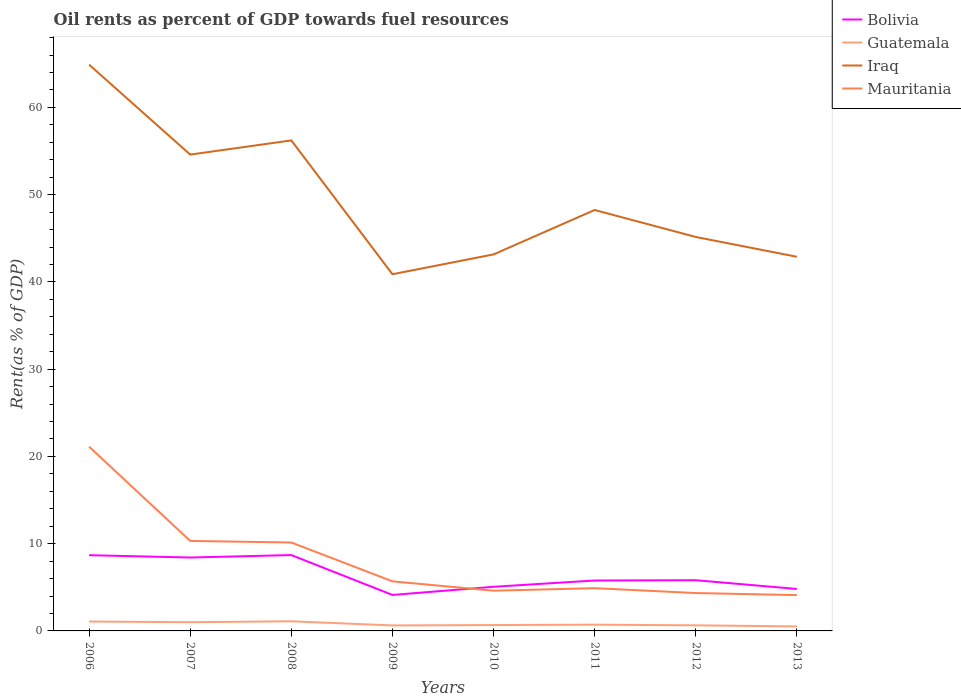Across all years, what is the maximum oil rent in Guatemala?
Offer a terse response. 0.52. In which year was the oil rent in Mauritania maximum?
Keep it short and to the point. 2013. What is the total oil rent in Guatemala in the graph?
Offer a terse response. 0.41. What is the difference between the highest and the second highest oil rent in Iraq?
Provide a short and direct response. 24.02. What is the difference between the highest and the lowest oil rent in Bolivia?
Keep it short and to the point. 3. How many lines are there?
Provide a short and direct response. 4. Are the values on the major ticks of Y-axis written in scientific E-notation?
Your answer should be very brief. No. How many legend labels are there?
Make the answer very short. 4. What is the title of the graph?
Your answer should be very brief. Oil rents as percent of GDP towards fuel resources. What is the label or title of the Y-axis?
Ensure brevity in your answer.  Rent(as % of GDP). What is the Rent(as % of GDP) in Bolivia in 2006?
Provide a succinct answer. 8.68. What is the Rent(as % of GDP) in Guatemala in 2006?
Your answer should be very brief. 1.08. What is the Rent(as % of GDP) of Iraq in 2006?
Provide a succinct answer. 64.9. What is the Rent(as % of GDP) in Mauritania in 2006?
Your answer should be very brief. 21.12. What is the Rent(as % of GDP) in Bolivia in 2007?
Offer a very short reply. 8.41. What is the Rent(as % of GDP) in Guatemala in 2007?
Provide a succinct answer. 1. What is the Rent(as % of GDP) in Iraq in 2007?
Offer a very short reply. 54.59. What is the Rent(as % of GDP) of Mauritania in 2007?
Keep it short and to the point. 10.32. What is the Rent(as % of GDP) in Bolivia in 2008?
Your answer should be very brief. 8.69. What is the Rent(as % of GDP) of Guatemala in 2008?
Your answer should be compact. 1.11. What is the Rent(as % of GDP) in Iraq in 2008?
Your response must be concise. 56.22. What is the Rent(as % of GDP) in Mauritania in 2008?
Keep it short and to the point. 10.13. What is the Rent(as % of GDP) in Bolivia in 2009?
Offer a terse response. 4.12. What is the Rent(as % of GDP) in Guatemala in 2009?
Your answer should be compact. 0.63. What is the Rent(as % of GDP) of Iraq in 2009?
Your answer should be very brief. 40.88. What is the Rent(as % of GDP) in Mauritania in 2009?
Offer a terse response. 5.68. What is the Rent(as % of GDP) in Bolivia in 2010?
Keep it short and to the point. 5.06. What is the Rent(as % of GDP) of Guatemala in 2010?
Offer a very short reply. 0.67. What is the Rent(as % of GDP) in Iraq in 2010?
Provide a succinct answer. 43.15. What is the Rent(as % of GDP) in Mauritania in 2010?
Make the answer very short. 4.61. What is the Rent(as % of GDP) of Bolivia in 2011?
Provide a succinct answer. 5.78. What is the Rent(as % of GDP) of Guatemala in 2011?
Make the answer very short. 0.72. What is the Rent(as % of GDP) in Iraq in 2011?
Give a very brief answer. 48.24. What is the Rent(as % of GDP) of Mauritania in 2011?
Offer a terse response. 4.9. What is the Rent(as % of GDP) in Bolivia in 2012?
Offer a very short reply. 5.81. What is the Rent(as % of GDP) of Guatemala in 2012?
Offer a terse response. 0.64. What is the Rent(as % of GDP) of Iraq in 2012?
Make the answer very short. 45.15. What is the Rent(as % of GDP) in Mauritania in 2012?
Offer a very short reply. 4.34. What is the Rent(as % of GDP) in Bolivia in 2013?
Make the answer very short. 4.81. What is the Rent(as % of GDP) in Guatemala in 2013?
Make the answer very short. 0.52. What is the Rent(as % of GDP) in Iraq in 2013?
Give a very brief answer. 42.88. What is the Rent(as % of GDP) in Mauritania in 2013?
Your response must be concise. 4.1. Across all years, what is the maximum Rent(as % of GDP) of Bolivia?
Your answer should be very brief. 8.69. Across all years, what is the maximum Rent(as % of GDP) in Guatemala?
Offer a terse response. 1.11. Across all years, what is the maximum Rent(as % of GDP) of Iraq?
Offer a very short reply. 64.9. Across all years, what is the maximum Rent(as % of GDP) of Mauritania?
Offer a terse response. 21.12. Across all years, what is the minimum Rent(as % of GDP) of Bolivia?
Provide a short and direct response. 4.12. Across all years, what is the minimum Rent(as % of GDP) in Guatemala?
Your answer should be compact. 0.52. Across all years, what is the minimum Rent(as % of GDP) of Iraq?
Offer a very short reply. 40.88. Across all years, what is the minimum Rent(as % of GDP) of Mauritania?
Your answer should be very brief. 4.1. What is the total Rent(as % of GDP) of Bolivia in the graph?
Offer a terse response. 51.37. What is the total Rent(as % of GDP) in Guatemala in the graph?
Your response must be concise. 6.35. What is the total Rent(as % of GDP) in Iraq in the graph?
Keep it short and to the point. 396.02. What is the total Rent(as % of GDP) in Mauritania in the graph?
Offer a very short reply. 65.2. What is the difference between the Rent(as % of GDP) in Bolivia in 2006 and that in 2007?
Give a very brief answer. 0.26. What is the difference between the Rent(as % of GDP) of Guatemala in 2006 and that in 2007?
Give a very brief answer. 0.08. What is the difference between the Rent(as % of GDP) in Iraq in 2006 and that in 2007?
Provide a short and direct response. 10.31. What is the difference between the Rent(as % of GDP) in Mauritania in 2006 and that in 2007?
Keep it short and to the point. 10.8. What is the difference between the Rent(as % of GDP) of Bolivia in 2006 and that in 2008?
Offer a terse response. -0.01. What is the difference between the Rent(as % of GDP) of Guatemala in 2006 and that in 2008?
Ensure brevity in your answer.  -0.03. What is the difference between the Rent(as % of GDP) of Iraq in 2006 and that in 2008?
Your answer should be very brief. 8.68. What is the difference between the Rent(as % of GDP) in Mauritania in 2006 and that in 2008?
Offer a very short reply. 10.98. What is the difference between the Rent(as % of GDP) in Bolivia in 2006 and that in 2009?
Give a very brief answer. 4.56. What is the difference between the Rent(as % of GDP) of Guatemala in 2006 and that in 2009?
Give a very brief answer. 0.45. What is the difference between the Rent(as % of GDP) of Iraq in 2006 and that in 2009?
Your response must be concise. 24.02. What is the difference between the Rent(as % of GDP) in Mauritania in 2006 and that in 2009?
Ensure brevity in your answer.  15.44. What is the difference between the Rent(as % of GDP) of Bolivia in 2006 and that in 2010?
Provide a short and direct response. 3.62. What is the difference between the Rent(as % of GDP) of Guatemala in 2006 and that in 2010?
Offer a terse response. 0.41. What is the difference between the Rent(as % of GDP) of Iraq in 2006 and that in 2010?
Make the answer very short. 21.75. What is the difference between the Rent(as % of GDP) of Mauritania in 2006 and that in 2010?
Make the answer very short. 16.51. What is the difference between the Rent(as % of GDP) in Guatemala in 2006 and that in 2011?
Offer a terse response. 0.36. What is the difference between the Rent(as % of GDP) in Iraq in 2006 and that in 2011?
Keep it short and to the point. 16.66. What is the difference between the Rent(as % of GDP) in Mauritania in 2006 and that in 2011?
Make the answer very short. 16.22. What is the difference between the Rent(as % of GDP) of Bolivia in 2006 and that in 2012?
Offer a very short reply. 2.87. What is the difference between the Rent(as % of GDP) of Guatemala in 2006 and that in 2012?
Make the answer very short. 0.44. What is the difference between the Rent(as % of GDP) of Iraq in 2006 and that in 2012?
Provide a succinct answer. 19.75. What is the difference between the Rent(as % of GDP) in Mauritania in 2006 and that in 2012?
Make the answer very short. 16.78. What is the difference between the Rent(as % of GDP) in Bolivia in 2006 and that in 2013?
Your answer should be very brief. 3.87. What is the difference between the Rent(as % of GDP) in Guatemala in 2006 and that in 2013?
Ensure brevity in your answer.  0.56. What is the difference between the Rent(as % of GDP) in Iraq in 2006 and that in 2013?
Provide a succinct answer. 22.02. What is the difference between the Rent(as % of GDP) of Mauritania in 2006 and that in 2013?
Make the answer very short. 17.01. What is the difference between the Rent(as % of GDP) of Bolivia in 2007 and that in 2008?
Offer a terse response. -0.28. What is the difference between the Rent(as % of GDP) in Guatemala in 2007 and that in 2008?
Your response must be concise. -0.11. What is the difference between the Rent(as % of GDP) of Iraq in 2007 and that in 2008?
Give a very brief answer. -1.63. What is the difference between the Rent(as % of GDP) of Mauritania in 2007 and that in 2008?
Keep it short and to the point. 0.18. What is the difference between the Rent(as % of GDP) of Bolivia in 2007 and that in 2009?
Keep it short and to the point. 4.29. What is the difference between the Rent(as % of GDP) of Guatemala in 2007 and that in 2009?
Offer a very short reply. 0.37. What is the difference between the Rent(as % of GDP) in Iraq in 2007 and that in 2009?
Offer a terse response. 13.71. What is the difference between the Rent(as % of GDP) of Mauritania in 2007 and that in 2009?
Offer a very short reply. 4.63. What is the difference between the Rent(as % of GDP) in Bolivia in 2007 and that in 2010?
Offer a very short reply. 3.36. What is the difference between the Rent(as % of GDP) in Guatemala in 2007 and that in 2010?
Provide a short and direct response. 0.33. What is the difference between the Rent(as % of GDP) of Iraq in 2007 and that in 2010?
Your response must be concise. 11.44. What is the difference between the Rent(as % of GDP) of Mauritania in 2007 and that in 2010?
Provide a succinct answer. 5.7. What is the difference between the Rent(as % of GDP) of Bolivia in 2007 and that in 2011?
Keep it short and to the point. 2.64. What is the difference between the Rent(as % of GDP) of Guatemala in 2007 and that in 2011?
Offer a very short reply. 0.28. What is the difference between the Rent(as % of GDP) in Iraq in 2007 and that in 2011?
Your response must be concise. 6.35. What is the difference between the Rent(as % of GDP) of Mauritania in 2007 and that in 2011?
Your response must be concise. 5.42. What is the difference between the Rent(as % of GDP) of Bolivia in 2007 and that in 2012?
Your answer should be very brief. 2.6. What is the difference between the Rent(as % of GDP) in Guatemala in 2007 and that in 2012?
Your answer should be compact. 0.36. What is the difference between the Rent(as % of GDP) of Iraq in 2007 and that in 2012?
Provide a short and direct response. 9.44. What is the difference between the Rent(as % of GDP) of Mauritania in 2007 and that in 2012?
Offer a very short reply. 5.97. What is the difference between the Rent(as % of GDP) in Bolivia in 2007 and that in 2013?
Offer a very short reply. 3.6. What is the difference between the Rent(as % of GDP) of Guatemala in 2007 and that in 2013?
Your response must be concise. 0.48. What is the difference between the Rent(as % of GDP) in Iraq in 2007 and that in 2013?
Offer a very short reply. 11.71. What is the difference between the Rent(as % of GDP) in Mauritania in 2007 and that in 2013?
Your answer should be compact. 6.21. What is the difference between the Rent(as % of GDP) of Bolivia in 2008 and that in 2009?
Give a very brief answer. 4.57. What is the difference between the Rent(as % of GDP) of Guatemala in 2008 and that in 2009?
Offer a terse response. 0.48. What is the difference between the Rent(as % of GDP) in Iraq in 2008 and that in 2009?
Provide a succinct answer. 15.34. What is the difference between the Rent(as % of GDP) of Mauritania in 2008 and that in 2009?
Give a very brief answer. 4.45. What is the difference between the Rent(as % of GDP) in Bolivia in 2008 and that in 2010?
Your response must be concise. 3.63. What is the difference between the Rent(as % of GDP) of Guatemala in 2008 and that in 2010?
Provide a short and direct response. 0.43. What is the difference between the Rent(as % of GDP) of Iraq in 2008 and that in 2010?
Your answer should be very brief. 13.07. What is the difference between the Rent(as % of GDP) in Mauritania in 2008 and that in 2010?
Your answer should be compact. 5.52. What is the difference between the Rent(as % of GDP) of Bolivia in 2008 and that in 2011?
Your answer should be compact. 2.91. What is the difference between the Rent(as % of GDP) of Guatemala in 2008 and that in 2011?
Your response must be concise. 0.39. What is the difference between the Rent(as % of GDP) of Iraq in 2008 and that in 2011?
Your answer should be compact. 7.98. What is the difference between the Rent(as % of GDP) of Mauritania in 2008 and that in 2011?
Provide a succinct answer. 5.23. What is the difference between the Rent(as % of GDP) of Bolivia in 2008 and that in 2012?
Provide a short and direct response. 2.88. What is the difference between the Rent(as % of GDP) of Guatemala in 2008 and that in 2012?
Keep it short and to the point. 0.46. What is the difference between the Rent(as % of GDP) of Iraq in 2008 and that in 2012?
Ensure brevity in your answer.  11.07. What is the difference between the Rent(as % of GDP) of Mauritania in 2008 and that in 2012?
Your answer should be very brief. 5.79. What is the difference between the Rent(as % of GDP) in Bolivia in 2008 and that in 2013?
Your answer should be compact. 3.88. What is the difference between the Rent(as % of GDP) in Guatemala in 2008 and that in 2013?
Your answer should be very brief. 0.59. What is the difference between the Rent(as % of GDP) in Iraq in 2008 and that in 2013?
Offer a very short reply. 13.34. What is the difference between the Rent(as % of GDP) in Mauritania in 2008 and that in 2013?
Offer a terse response. 6.03. What is the difference between the Rent(as % of GDP) in Bolivia in 2009 and that in 2010?
Your answer should be very brief. -0.93. What is the difference between the Rent(as % of GDP) of Guatemala in 2009 and that in 2010?
Ensure brevity in your answer.  -0.04. What is the difference between the Rent(as % of GDP) in Iraq in 2009 and that in 2010?
Keep it short and to the point. -2.27. What is the difference between the Rent(as % of GDP) of Mauritania in 2009 and that in 2010?
Keep it short and to the point. 1.07. What is the difference between the Rent(as % of GDP) in Bolivia in 2009 and that in 2011?
Your response must be concise. -1.66. What is the difference between the Rent(as % of GDP) of Guatemala in 2009 and that in 2011?
Give a very brief answer. -0.09. What is the difference between the Rent(as % of GDP) in Iraq in 2009 and that in 2011?
Provide a short and direct response. -7.36. What is the difference between the Rent(as % of GDP) in Mauritania in 2009 and that in 2011?
Offer a terse response. 0.78. What is the difference between the Rent(as % of GDP) of Bolivia in 2009 and that in 2012?
Make the answer very short. -1.69. What is the difference between the Rent(as % of GDP) in Guatemala in 2009 and that in 2012?
Provide a succinct answer. -0.01. What is the difference between the Rent(as % of GDP) in Iraq in 2009 and that in 2012?
Your answer should be very brief. -4.27. What is the difference between the Rent(as % of GDP) of Mauritania in 2009 and that in 2012?
Keep it short and to the point. 1.34. What is the difference between the Rent(as % of GDP) in Bolivia in 2009 and that in 2013?
Your answer should be very brief. -0.69. What is the difference between the Rent(as % of GDP) in Guatemala in 2009 and that in 2013?
Offer a very short reply. 0.11. What is the difference between the Rent(as % of GDP) of Iraq in 2009 and that in 2013?
Ensure brevity in your answer.  -2. What is the difference between the Rent(as % of GDP) of Mauritania in 2009 and that in 2013?
Give a very brief answer. 1.58. What is the difference between the Rent(as % of GDP) in Bolivia in 2010 and that in 2011?
Provide a succinct answer. -0.72. What is the difference between the Rent(as % of GDP) in Guatemala in 2010 and that in 2011?
Offer a terse response. -0.04. What is the difference between the Rent(as % of GDP) of Iraq in 2010 and that in 2011?
Offer a terse response. -5.09. What is the difference between the Rent(as % of GDP) of Mauritania in 2010 and that in 2011?
Offer a very short reply. -0.29. What is the difference between the Rent(as % of GDP) of Bolivia in 2010 and that in 2012?
Ensure brevity in your answer.  -0.75. What is the difference between the Rent(as % of GDP) in Guatemala in 2010 and that in 2012?
Your answer should be compact. 0.03. What is the difference between the Rent(as % of GDP) in Iraq in 2010 and that in 2012?
Give a very brief answer. -2. What is the difference between the Rent(as % of GDP) in Mauritania in 2010 and that in 2012?
Offer a very short reply. 0.27. What is the difference between the Rent(as % of GDP) of Bolivia in 2010 and that in 2013?
Your answer should be compact. 0.25. What is the difference between the Rent(as % of GDP) of Guatemala in 2010 and that in 2013?
Your answer should be compact. 0.16. What is the difference between the Rent(as % of GDP) in Iraq in 2010 and that in 2013?
Give a very brief answer. 0.27. What is the difference between the Rent(as % of GDP) in Mauritania in 2010 and that in 2013?
Your response must be concise. 0.51. What is the difference between the Rent(as % of GDP) of Bolivia in 2011 and that in 2012?
Your answer should be very brief. -0.03. What is the difference between the Rent(as % of GDP) of Guatemala in 2011 and that in 2012?
Your answer should be very brief. 0.07. What is the difference between the Rent(as % of GDP) of Iraq in 2011 and that in 2012?
Keep it short and to the point. 3.09. What is the difference between the Rent(as % of GDP) of Mauritania in 2011 and that in 2012?
Offer a very short reply. 0.56. What is the difference between the Rent(as % of GDP) in Bolivia in 2011 and that in 2013?
Keep it short and to the point. 0.97. What is the difference between the Rent(as % of GDP) in Guatemala in 2011 and that in 2013?
Provide a short and direct response. 0.2. What is the difference between the Rent(as % of GDP) in Iraq in 2011 and that in 2013?
Ensure brevity in your answer.  5.36. What is the difference between the Rent(as % of GDP) in Mauritania in 2011 and that in 2013?
Give a very brief answer. 0.8. What is the difference between the Rent(as % of GDP) of Bolivia in 2012 and that in 2013?
Your answer should be very brief. 1. What is the difference between the Rent(as % of GDP) of Guatemala in 2012 and that in 2013?
Your answer should be compact. 0.12. What is the difference between the Rent(as % of GDP) of Iraq in 2012 and that in 2013?
Make the answer very short. 2.27. What is the difference between the Rent(as % of GDP) of Mauritania in 2012 and that in 2013?
Ensure brevity in your answer.  0.24. What is the difference between the Rent(as % of GDP) in Bolivia in 2006 and the Rent(as % of GDP) in Guatemala in 2007?
Make the answer very short. 7.68. What is the difference between the Rent(as % of GDP) in Bolivia in 2006 and the Rent(as % of GDP) in Iraq in 2007?
Your response must be concise. -45.91. What is the difference between the Rent(as % of GDP) of Bolivia in 2006 and the Rent(as % of GDP) of Mauritania in 2007?
Provide a short and direct response. -1.64. What is the difference between the Rent(as % of GDP) in Guatemala in 2006 and the Rent(as % of GDP) in Iraq in 2007?
Your answer should be very brief. -53.51. What is the difference between the Rent(as % of GDP) of Guatemala in 2006 and the Rent(as % of GDP) of Mauritania in 2007?
Keep it short and to the point. -9.24. What is the difference between the Rent(as % of GDP) of Iraq in 2006 and the Rent(as % of GDP) of Mauritania in 2007?
Keep it short and to the point. 54.59. What is the difference between the Rent(as % of GDP) of Bolivia in 2006 and the Rent(as % of GDP) of Guatemala in 2008?
Your answer should be very brief. 7.57. What is the difference between the Rent(as % of GDP) in Bolivia in 2006 and the Rent(as % of GDP) in Iraq in 2008?
Give a very brief answer. -47.54. What is the difference between the Rent(as % of GDP) of Bolivia in 2006 and the Rent(as % of GDP) of Mauritania in 2008?
Your answer should be compact. -1.46. What is the difference between the Rent(as % of GDP) in Guatemala in 2006 and the Rent(as % of GDP) in Iraq in 2008?
Offer a terse response. -55.14. What is the difference between the Rent(as % of GDP) of Guatemala in 2006 and the Rent(as % of GDP) of Mauritania in 2008?
Provide a succinct answer. -9.06. What is the difference between the Rent(as % of GDP) in Iraq in 2006 and the Rent(as % of GDP) in Mauritania in 2008?
Offer a very short reply. 54.77. What is the difference between the Rent(as % of GDP) in Bolivia in 2006 and the Rent(as % of GDP) in Guatemala in 2009?
Give a very brief answer. 8.05. What is the difference between the Rent(as % of GDP) of Bolivia in 2006 and the Rent(as % of GDP) of Iraq in 2009?
Keep it short and to the point. -32.2. What is the difference between the Rent(as % of GDP) of Bolivia in 2006 and the Rent(as % of GDP) of Mauritania in 2009?
Your response must be concise. 3. What is the difference between the Rent(as % of GDP) of Guatemala in 2006 and the Rent(as % of GDP) of Iraq in 2009?
Offer a terse response. -39.8. What is the difference between the Rent(as % of GDP) of Guatemala in 2006 and the Rent(as % of GDP) of Mauritania in 2009?
Your answer should be very brief. -4.6. What is the difference between the Rent(as % of GDP) of Iraq in 2006 and the Rent(as % of GDP) of Mauritania in 2009?
Your answer should be very brief. 59.22. What is the difference between the Rent(as % of GDP) of Bolivia in 2006 and the Rent(as % of GDP) of Guatemala in 2010?
Offer a very short reply. 8.01. What is the difference between the Rent(as % of GDP) of Bolivia in 2006 and the Rent(as % of GDP) of Iraq in 2010?
Ensure brevity in your answer.  -34.47. What is the difference between the Rent(as % of GDP) of Bolivia in 2006 and the Rent(as % of GDP) of Mauritania in 2010?
Ensure brevity in your answer.  4.07. What is the difference between the Rent(as % of GDP) of Guatemala in 2006 and the Rent(as % of GDP) of Iraq in 2010?
Provide a short and direct response. -42.07. What is the difference between the Rent(as % of GDP) of Guatemala in 2006 and the Rent(as % of GDP) of Mauritania in 2010?
Provide a short and direct response. -3.53. What is the difference between the Rent(as % of GDP) in Iraq in 2006 and the Rent(as % of GDP) in Mauritania in 2010?
Keep it short and to the point. 60.29. What is the difference between the Rent(as % of GDP) of Bolivia in 2006 and the Rent(as % of GDP) of Guatemala in 2011?
Ensure brevity in your answer.  7.96. What is the difference between the Rent(as % of GDP) of Bolivia in 2006 and the Rent(as % of GDP) of Iraq in 2011?
Your answer should be very brief. -39.56. What is the difference between the Rent(as % of GDP) of Bolivia in 2006 and the Rent(as % of GDP) of Mauritania in 2011?
Offer a terse response. 3.78. What is the difference between the Rent(as % of GDP) in Guatemala in 2006 and the Rent(as % of GDP) in Iraq in 2011?
Keep it short and to the point. -47.16. What is the difference between the Rent(as % of GDP) in Guatemala in 2006 and the Rent(as % of GDP) in Mauritania in 2011?
Keep it short and to the point. -3.82. What is the difference between the Rent(as % of GDP) in Iraq in 2006 and the Rent(as % of GDP) in Mauritania in 2011?
Make the answer very short. 60. What is the difference between the Rent(as % of GDP) in Bolivia in 2006 and the Rent(as % of GDP) in Guatemala in 2012?
Offer a very short reply. 8.04. What is the difference between the Rent(as % of GDP) of Bolivia in 2006 and the Rent(as % of GDP) of Iraq in 2012?
Provide a short and direct response. -36.47. What is the difference between the Rent(as % of GDP) in Bolivia in 2006 and the Rent(as % of GDP) in Mauritania in 2012?
Ensure brevity in your answer.  4.34. What is the difference between the Rent(as % of GDP) of Guatemala in 2006 and the Rent(as % of GDP) of Iraq in 2012?
Make the answer very short. -44.07. What is the difference between the Rent(as % of GDP) of Guatemala in 2006 and the Rent(as % of GDP) of Mauritania in 2012?
Provide a succinct answer. -3.26. What is the difference between the Rent(as % of GDP) in Iraq in 2006 and the Rent(as % of GDP) in Mauritania in 2012?
Keep it short and to the point. 60.56. What is the difference between the Rent(as % of GDP) of Bolivia in 2006 and the Rent(as % of GDP) of Guatemala in 2013?
Provide a succinct answer. 8.16. What is the difference between the Rent(as % of GDP) of Bolivia in 2006 and the Rent(as % of GDP) of Iraq in 2013?
Your response must be concise. -34.2. What is the difference between the Rent(as % of GDP) of Bolivia in 2006 and the Rent(as % of GDP) of Mauritania in 2013?
Provide a short and direct response. 4.57. What is the difference between the Rent(as % of GDP) of Guatemala in 2006 and the Rent(as % of GDP) of Iraq in 2013?
Keep it short and to the point. -41.8. What is the difference between the Rent(as % of GDP) of Guatemala in 2006 and the Rent(as % of GDP) of Mauritania in 2013?
Your answer should be very brief. -3.03. What is the difference between the Rent(as % of GDP) in Iraq in 2006 and the Rent(as % of GDP) in Mauritania in 2013?
Make the answer very short. 60.8. What is the difference between the Rent(as % of GDP) of Bolivia in 2007 and the Rent(as % of GDP) of Guatemala in 2008?
Keep it short and to the point. 7.31. What is the difference between the Rent(as % of GDP) in Bolivia in 2007 and the Rent(as % of GDP) in Iraq in 2008?
Provide a succinct answer. -47.81. What is the difference between the Rent(as % of GDP) of Bolivia in 2007 and the Rent(as % of GDP) of Mauritania in 2008?
Give a very brief answer. -1.72. What is the difference between the Rent(as % of GDP) in Guatemala in 2007 and the Rent(as % of GDP) in Iraq in 2008?
Make the answer very short. -55.22. What is the difference between the Rent(as % of GDP) of Guatemala in 2007 and the Rent(as % of GDP) of Mauritania in 2008?
Provide a short and direct response. -9.14. What is the difference between the Rent(as % of GDP) of Iraq in 2007 and the Rent(as % of GDP) of Mauritania in 2008?
Your answer should be very brief. 44.46. What is the difference between the Rent(as % of GDP) of Bolivia in 2007 and the Rent(as % of GDP) of Guatemala in 2009?
Ensure brevity in your answer.  7.79. What is the difference between the Rent(as % of GDP) in Bolivia in 2007 and the Rent(as % of GDP) in Iraq in 2009?
Offer a very short reply. -32.47. What is the difference between the Rent(as % of GDP) in Bolivia in 2007 and the Rent(as % of GDP) in Mauritania in 2009?
Your response must be concise. 2.73. What is the difference between the Rent(as % of GDP) of Guatemala in 2007 and the Rent(as % of GDP) of Iraq in 2009?
Give a very brief answer. -39.88. What is the difference between the Rent(as % of GDP) of Guatemala in 2007 and the Rent(as % of GDP) of Mauritania in 2009?
Offer a very short reply. -4.68. What is the difference between the Rent(as % of GDP) in Iraq in 2007 and the Rent(as % of GDP) in Mauritania in 2009?
Ensure brevity in your answer.  48.91. What is the difference between the Rent(as % of GDP) of Bolivia in 2007 and the Rent(as % of GDP) of Guatemala in 2010?
Your response must be concise. 7.74. What is the difference between the Rent(as % of GDP) in Bolivia in 2007 and the Rent(as % of GDP) in Iraq in 2010?
Your response must be concise. -34.74. What is the difference between the Rent(as % of GDP) of Bolivia in 2007 and the Rent(as % of GDP) of Mauritania in 2010?
Keep it short and to the point. 3.8. What is the difference between the Rent(as % of GDP) in Guatemala in 2007 and the Rent(as % of GDP) in Iraq in 2010?
Provide a short and direct response. -42.16. What is the difference between the Rent(as % of GDP) in Guatemala in 2007 and the Rent(as % of GDP) in Mauritania in 2010?
Provide a short and direct response. -3.61. What is the difference between the Rent(as % of GDP) in Iraq in 2007 and the Rent(as % of GDP) in Mauritania in 2010?
Provide a short and direct response. 49.98. What is the difference between the Rent(as % of GDP) of Bolivia in 2007 and the Rent(as % of GDP) of Guatemala in 2011?
Ensure brevity in your answer.  7.7. What is the difference between the Rent(as % of GDP) of Bolivia in 2007 and the Rent(as % of GDP) of Iraq in 2011?
Provide a short and direct response. -39.83. What is the difference between the Rent(as % of GDP) in Bolivia in 2007 and the Rent(as % of GDP) in Mauritania in 2011?
Give a very brief answer. 3.51. What is the difference between the Rent(as % of GDP) in Guatemala in 2007 and the Rent(as % of GDP) in Iraq in 2011?
Keep it short and to the point. -47.25. What is the difference between the Rent(as % of GDP) of Guatemala in 2007 and the Rent(as % of GDP) of Mauritania in 2011?
Provide a succinct answer. -3.9. What is the difference between the Rent(as % of GDP) of Iraq in 2007 and the Rent(as % of GDP) of Mauritania in 2011?
Your answer should be very brief. 49.69. What is the difference between the Rent(as % of GDP) of Bolivia in 2007 and the Rent(as % of GDP) of Guatemala in 2012?
Ensure brevity in your answer.  7.77. What is the difference between the Rent(as % of GDP) of Bolivia in 2007 and the Rent(as % of GDP) of Iraq in 2012?
Offer a very short reply. -36.74. What is the difference between the Rent(as % of GDP) in Bolivia in 2007 and the Rent(as % of GDP) in Mauritania in 2012?
Offer a very short reply. 4.07. What is the difference between the Rent(as % of GDP) in Guatemala in 2007 and the Rent(as % of GDP) in Iraq in 2012?
Offer a very short reply. -44.16. What is the difference between the Rent(as % of GDP) of Guatemala in 2007 and the Rent(as % of GDP) of Mauritania in 2012?
Your answer should be compact. -3.34. What is the difference between the Rent(as % of GDP) of Iraq in 2007 and the Rent(as % of GDP) of Mauritania in 2012?
Your answer should be very brief. 50.25. What is the difference between the Rent(as % of GDP) of Bolivia in 2007 and the Rent(as % of GDP) of Guatemala in 2013?
Give a very brief answer. 7.9. What is the difference between the Rent(as % of GDP) of Bolivia in 2007 and the Rent(as % of GDP) of Iraq in 2013?
Provide a succinct answer. -34.47. What is the difference between the Rent(as % of GDP) of Bolivia in 2007 and the Rent(as % of GDP) of Mauritania in 2013?
Offer a very short reply. 4.31. What is the difference between the Rent(as % of GDP) of Guatemala in 2007 and the Rent(as % of GDP) of Iraq in 2013?
Offer a very short reply. -41.89. What is the difference between the Rent(as % of GDP) of Guatemala in 2007 and the Rent(as % of GDP) of Mauritania in 2013?
Make the answer very short. -3.11. What is the difference between the Rent(as % of GDP) of Iraq in 2007 and the Rent(as % of GDP) of Mauritania in 2013?
Make the answer very short. 50.49. What is the difference between the Rent(as % of GDP) in Bolivia in 2008 and the Rent(as % of GDP) in Guatemala in 2009?
Provide a succinct answer. 8.06. What is the difference between the Rent(as % of GDP) in Bolivia in 2008 and the Rent(as % of GDP) in Iraq in 2009?
Your response must be concise. -32.19. What is the difference between the Rent(as % of GDP) of Bolivia in 2008 and the Rent(as % of GDP) of Mauritania in 2009?
Offer a terse response. 3.01. What is the difference between the Rent(as % of GDP) of Guatemala in 2008 and the Rent(as % of GDP) of Iraq in 2009?
Make the answer very short. -39.78. What is the difference between the Rent(as % of GDP) of Guatemala in 2008 and the Rent(as % of GDP) of Mauritania in 2009?
Ensure brevity in your answer.  -4.58. What is the difference between the Rent(as % of GDP) of Iraq in 2008 and the Rent(as % of GDP) of Mauritania in 2009?
Your answer should be very brief. 50.54. What is the difference between the Rent(as % of GDP) in Bolivia in 2008 and the Rent(as % of GDP) in Guatemala in 2010?
Keep it short and to the point. 8.02. What is the difference between the Rent(as % of GDP) in Bolivia in 2008 and the Rent(as % of GDP) in Iraq in 2010?
Give a very brief answer. -34.46. What is the difference between the Rent(as % of GDP) in Bolivia in 2008 and the Rent(as % of GDP) in Mauritania in 2010?
Give a very brief answer. 4.08. What is the difference between the Rent(as % of GDP) of Guatemala in 2008 and the Rent(as % of GDP) of Iraq in 2010?
Make the answer very short. -42.05. What is the difference between the Rent(as % of GDP) of Guatemala in 2008 and the Rent(as % of GDP) of Mauritania in 2010?
Offer a terse response. -3.5. What is the difference between the Rent(as % of GDP) of Iraq in 2008 and the Rent(as % of GDP) of Mauritania in 2010?
Ensure brevity in your answer.  51.61. What is the difference between the Rent(as % of GDP) of Bolivia in 2008 and the Rent(as % of GDP) of Guatemala in 2011?
Your answer should be very brief. 7.98. What is the difference between the Rent(as % of GDP) in Bolivia in 2008 and the Rent(as % of GDP) in Iraq in 2011?
Ensure brevity in your answer.  -39.55. What is the difference between the Rent(as % of GDP) of Bolivia in 2008 and the Rent(as % of GDP) of Mauritania in 2011?
Keep it short and to the point. 3.79. What is the difference between the Rent(as % of GDP) in Guatemala in 2008 and the Rent(as % of GDP) in Iraq in 2011?
Ensure brevity in your answer.  -47.14. What is the difference between the Rent(as % of GDP) of Guatemala in 2008 and the Rent(as % of GDP) of Mauritania in 2011?
Provide a succinct answer. -3.79. What is the difference between the Rent(as % of GDP) in Iraq in 2008 and the Rent(as % of GDP) in Mauritania in 2011?
Your response must be concise. 51.32. What is the difference between the Rent(as % of GDP) in Bolivia in 2008 and the Rent(as % of GDP) in Guatemala in 2012?
Your answer should be compact. 8.05. What is the difference between the Rent(as % of GDP) in Bolivia in 2008 and the Rent(as % of GDP) in Iraq in 2012?
Ensure brevity in your answer.  -36.46. What is the difference between the Rent(as % of GDP) of Bolivia in 2008 and the Rent(as % of GDP) of Mauritania in 2012?
Provide a succinct answer. 4.35. What is the difference between the Rent(as % of GDP) of Guatemala in 2008 and the Rent(as % of GDP) of Iraq in 2012?
Your response must be concise. -44.05. What is the difference between the Rent(as % of GDP) in Guatemala in 2008 and the Rent(as % of GDP) in Mauritania in 2012?
Ensure brevity in your answer.  -3.24. What is the difference between the Rent(as % of GDP) of Iraq in 2008 and the Rent(as % of GDP) of Mauritania in 2012?
Ensure brevity in your answer.  51.88. What is the difference between the Rent(as % of GDP) of Bolivia in 2008 and the Rent(as % of GDP) of Guatemala in 2013?
Your answer should be compact. 8.18. What is the difference between the Rent(as % of GDP) of Bolivia in 2008 and the Rent(as % of GDP) of Iraq in 2013?
Your answer should be very brief. -34.19. What is the difference between the Rent(as % of GDP) in Bolivia in 2008 and the Rent(as % of GDP) in Mauritania in 2013?
Provide a short and direct response. 4.59. What is the difference between the Rent(as % of GDP) in Guatemala in 2008 and the Rent(as % of GDP) in Iraq in 2013?
Ensure brevity in your answer.  -41.78. What is the difference between the Rent(as % of GDP) of Guatemala in 2008 and the Rent(as % of GDP) of Mauritania in 2013?
Keep it short and to the point. -3. What is the difference between the Rent(as % of GDP) of Iraq in 2008 and the Rent(as % of GDP) of Mauritania in 2013?
Keep it short and to the point. 52.11. What is the difference between the Rent(as % of GDP) in Bolivia in 2009 and the Rent(as % of GDP) in Guatemala in 2010?
Your answer should be very brief. 3.45. What is the difference between the Rent(as % of GDP) of Bolivia in 2009 and the Rent(as % of GDP) of Iraq in 2010?
Give a very brief answer. -39.03. What is the difference between the Rent(as % of GDP) in Bolivia in 2009 and the Rent(as % of GDP) in Mauritania in 2010?
Your response must be concise. -0.49. What is the difference between the Rent(as % of GDP) in Guatemala in 2009 and the Rent(as % of GDP) in Iraq in 2010?
Ensure brevity in your answer.  -42.52. What is the difference between the Rent(as % of GDP) in Guatemala in 2009 and the Rent(as % of GDP) in Mauritania in 2010?
Give a very brief answer. -3.98. What is the difference between the Rent(as % of GDP) in Iraq in 2009 and the Rent(as % of GDP) in Mauritania in 2010?
Provide a succinct answer. 36.27. What is the difference between the Rent(as % of GDP) in Bolivia in 2009 and the Rent(as % of GDP) in Guatemala in 2011?
Keep it short and to the point. 3.41. What is the difference between the Rent(as % of GDP) of Bolivia in 2009 and the Rent(as % of GDP) of Iraq in 2011?
Offer a terse response. -44.12. What is the difference between the Rent(as % of GDP) in Bolivia in 2009 and the Rent(as % of GDP) in Mauritania in 2011?
Provide a succinct answer. -0.78. What is the difference between the Rent(as % of GDP) in Guatemala in 2009 and the Rent(as % of GDP) in Iraq in 2011?
Offer a very short reply. -47.62. What is the difference between the Rent(as % of GDP) of Guatemala in 2009 and the Rent(as % of GDP) of Mauritania in 2011?
Provide a succinct answer. -4.27. What is the difference between the Rent(as % of GDP) in Iraq in 2009 and the Rent(as % of GDP) in Mauritania in 2011?
Keep it short and to the point. 35.98. What is the difference between the Rent(as % of GDP) in Bolivia in 2009 and the Rent(as % of GDP) in Guatemala in 2012?
Your answer should be very brief. 3.48. What is the difference between the Rent(as % of GDP) of Bolivia in 2009 and the Rent(as % of GDP) of Iraq in 2012?
Your answer should be compact. -41.03. What is the difference between the Rent(as % of GDP) in Bolivia in 2009 and the Rent(as % of GDP) in Mauritania in 2012?
Keep it short and to the point. -0.22. What is the difference between the Rent(as % of GDP) in Guatemala in 2009 and the Rent(as % of GDP) in Iraq in 2012?
Provide a short and direct response. -44.52. What is the difference between the Rent(as % of GDP) in Guatemala in 2009 and the Rent(as % of GDP) in Mauritania in 2012?
Provide a succinct answer. -3.71. What is the difference between the Rent(as % of GDP) in Iraq in 2009 and the Rent(as % of GDP) in Mauritania in 2012?
Provide a succinct answer. 36.54. What is the difference between the Rent(as % of GDP) of Bolivia in 2009 and the Rent(as % of GDP) of Guatemala in 2013?
Offer a very short reply. 3.61. What is the difference between the Rent(as % of GDP) in Bolivia in 2009 and the Rent(as % of GDP) in Iraq in 2013?
Provide a short and direct response. -38.76. What is the difference between the Rent(as % of GDP) of Bolivia in 2009 and the Rent(as % of GDP) of Mauritania in 2013?
Your answer should be compact. 0.02. What is the difference between the Rent(as % of GDP) in Guatemala in 2009 and the Rent(as % of GDP) in Iraq in 2013?
Provide a succinct answer. -42.25. What is the difference between the Rent(as % of GDP) in Guatemala in 2009 and the Rent(as % of GDP) in Mauritania in 2013?
Your answer should be very brief. -3.48. What is the difference between the Rent(as % of GDP) of Iraq in 2009 and the Rent(as % of GDP) of Mauritania in 2013?
Offer a very short reply. 36.78. What is the difference between the Rent(as % of GDP) in Bolivia in 2010 and the Rent(as % of GDP) in Guatemala in 2011?
Your answer should be very brief. 4.34. What is the difference between the Rent(as % of GDP) in Bolivia in 2010 and the Rent(as % of GDP) in Iraq in 2011?
Make the answer very short. -43.19. What is the difference between the Rent(as % of GDP) of Bolivia in 2010 and the Rent(as % of GDP) of Mauritania in 2011?
Give a very brief answer. 0.16. What is the difference between the Rent(as % of GDP) in Guatemala in 2010 and the Rent(as % of GDP) in Iraq in 2011?
Ensure brevity in your answer.  -47.57. What is the difference between the Rent(as % of GDP) of Guatemala in 2010 and the Rent(as % of GDP) of Mauritania in 2011?
Offer a very short reply. -4.23. What is the difference between the Rent(as % of GDP) of Iraq in 2010 and the Rent(as % of GDP) of Mauritania in 2011?
Ensure brevity in your answer.  38.25. What is the difference between the Rent(as % of GDP) in Bolivia in 2010 and the Rent(as % of GDP) in Guatemala in 2012?
Your answer should be compact. 4.42. What is the difference between the Rent(as % of GDP) of Bolivia in 2010 and the Rent(as % of GDP) of Iraq in 2012?
Offer a terse response. -40.09. What is the difference between the Rent(as % of GDP) of Bolivia in 2010 and the Rent(as % of GDP) of Mauritania in 2012?
Give a very brief answer. 0.72. What is the difference between the Rent(as % of GDP) of Guatemala in 2010 and the Rent(as % of GDP) of Iraq in 2012?
Make the answer very short. -44.48. What is the difference between the Rent(as % of GDP) in Guatemala in 2010 and the Rent(as % of GDP) in Mauritania in 2012?
Ensure brevity in your answer.  -3.67. What is the difference between the Rent(as % of GDP) of Iraq in 2010 and the Rent(as % of GDP) of Mauritania in 2012?
Offer a terse response. 38.81. What is the difference between the Rent(as % of GDP) in Bolivia in 2010 and the Rent(as % of GDP) in Guatemala in 2013?
Ensure brevity in your answer.  4.54. What is the difference between the Rent(as % of GDP) of Bolivia in 2010 and the Rent(as % of GDP) of Iraq in 2013?
Your response must be concise. -37.82. What is the difference between the Rent(as % of GDP) of Bolivia in 2010 and the Rent(as % of GDP) of Mauritania in 2013?
Provide a short and direct response. 0.95. What is the difference between the Rent(as % of GDP) of Guatemala in 2010 and the Rent(as % of GDP) of Iraq in 2013?
Your response must be concise. -42.21. What is the difference between the Rent(as % of GDP) in Guatemala in 2010 and the Rent(as % of GDP) in Mauritania in 2013?
Your answer should be compact. -3.43. What is the difference between the Rent(as % of GDP) in Iraq in 2010 and the Rent(as % of GDP) in Mauritania in 2013?
Give a very brief answer. 39.05. What is the difference between the Rent(as % of GDP) in Bolivia in 2011 and the Rent(as % of GDP) in Guatemala in 2012?
Make the answer very short. 5.14. What is the difference between the Rent(as % of GDP) of Bolivia in 2011 and the Rent(as % of GDP) of Iraq in 2012?
Your response must be concise. -39.37. What is the difference between the Rent(as % of GDP) in Bolivia in 2011 and the Rent(as % of GDP) in Mauritania in 2012?
Offer a very short reply. 1.44. What is the difference between the Rent(as % of GDP) of Guatemala in 2011 and the Rent(as % of GDP) of Iraq in 2012?
Make the answer very short. -44.44. What is the difference between the Rent(as % of GDP) of Guatemala in 2011 and the Rent(as % of GDP) of Mauritania in 2012?
Offer a very short reply. -3.63. What is the difference between the Rent(as % of GDP) of Iraq in 2011 and the Rent(as % of GDP) of Mauritania in 2012?
Offer a terse response. 43.9. What is the difference between the Rent(as % of GDP) of Bolivia in 2011 and the Rent(as % of GDP) of Guatemala in 2013?
Keep it short and to the point. 5.26. What is the difference between the Rent(as % of GDP) of Bolivia in 2011 and the Rent(as % of GDP) of Iraq in 2013?
Provide a short and direct response. -37.1. What is the difference between the Rent(as % of GDP) of Bolivia in 2011 and the Rent(as % of GDP) of Mauritania in 2013?
Provide a succinct answer. 1.67. What is the difference between the Rent(as % of GDP) of Guatemala in 2011 and the Rent(as % of GDP) of Iraq in 2013?
Provide a short and direct response. -42.17. What is the difference between the Rent(as % of GDP) in Guatemala in 2011 and the Rent(as % of GDP) in Mauritania in 2013?
Give a very brief answer. -3.39. What is the difference between the Rent(as % of GDP) in Iraq in 2011 and the Rent(as % of GDP) in Mauritania in 2013?
Your answer should be very brief. 44.14. What is the difference between the Rent(as % of GDP) in Bolivia in 2012 and the Rent(as % of GDP) in Guatemala in 2013?
Your answer should be very brief. 5.29. What is the difference between the Rent(as % of GDP) of Bolivia in 2012 and the Rent(as % of GDP) of Iraq in 2013?
Offer a terse response. -37.07. What is the difference between the Rent(as % of GDP) in Bolivia in 2012 and the Rent(as % of GDP) in Mauritania in 2013?
Offer a terse response. 1.71. What is the difference between the Rent(as % of GDP) of Guatemala in 2012 and the Rent(as % of GDP) of Iraq in 2013?
Give a very brief answer. -42.24. What is the difference between the Rent(as % of GDP) in Guatemala in 2012 and the Rent(as % of GDP) in Mauritania in 2013?
Ensure brevity in your answer.  -3.46. What is the difference between the Rent(as % of GDP) of Iraq in 2012 and the Rent(as % of GDP) of Mauritania in 2013?
Your response must be concise. 41.05. What is the average Rent(as % of GDP) of Bolivia per year?
Your answer should be compact. 6.42. What is the average Rent(as % of GDP) of Guatemala per year?
Give a very brief answer. 0.79. What is the average Rent(as % of GDP) in Iraq per year?
Provide a short and direct response. 49.5. What is the average Rent(as % of GDP) in Mauritania per year?
Keep it short and to the point. 8.15. In the year 2006, what is the difference between the Rent(as % of GDP) of Bolivia and Rent(as % of GDP) of Guatemala?
Provide a short and direct response. 7.6. In the year 2006, what is the difference between the Rent(as % of GDP) in Bolivia and Rent(as % of GDP) in Iraq?
Your response must be concise. -56.22. In the year 2006, what is the difference between the Rent(as % of GDP) in Bolivia and Rent(as % of GDP) in Mauritania?
Offer a terse response. -12.44. In the year 2006, what is the difference between the Rent(as % of GDP) of Guatemala and Rent(as % of GDP) of Iraq?
Your response must be concise. -63.82. In the year 2006, what is the difference between the Rent(as % of GDP) in Guatemala and Rent(as % of GDP) in Mauritania?
Your answer should be very brief. -20.04. In the year 2006, what is the difference between the Rent(as % of GDP) in Iraq and Rent(as % of GDP) in Mauritania?
Ensure brevity in your answer.  43.78. In the year 2007, what is the difference between the Rent(as % of GDP) in Bolivia and Rent(as % of GDP) in Guatemala?
Provide a succinct answer. 7.42. In the year 2007, what is the difference between the Rent(as % of GDP) in Bolivia and Rent(as % of GDP) in Iraq?
Ensure brevity in your answer.  -46.18. In the year 2007, what is the difference between the Rent(as % of GDP) in Bolivia and Rent(as % of GDP) in Mauritania?
Your response must be concise. -1.9. In the year 2007, what is the difference between the Rent(as % of GDP) of Guatemala and Rent(as % of GDP) of Iraq?
Your answer should be very brief. -53.6. In the year 2007, what is the difference between the Rent(as % of GDP) of Guatemala and Rent(as % of GDP) of Mauritania?
Your answer should be compact. -9.32. In the year 2007, what is the difference between the Rent(as % of GDP) of Iraq and Rent(as % of GDP) of Mauritania?
Your answer should be compact. 44.28. In the year 2008, what is the difference between the Rent(as % of GDP) of Bolivia and Rent(as % of GDP) of Guatemala?
Offer a very short reply. 7.59. In the year 2008, what is the difference between the Rent(as % of GDP) of Bolivia and Rent(as % of GDP) of Iraq?
Keep it short and to the point. -47.53. In the year 2008, what is the difference between the Rent(as % of GDP) of Bolivia and Rent(as % of GDP) of Mauritania?
Keep it short and to the point. -1.44. In the year 2008, what is the difference between the Rent(as % of GDP) in Guatemala and Rent(as % of GDP) in Iraq?
Your response must be concise. -55.11. In the year 2008, what is the difference between the Rent(as % of GDP) in Guatemala and Rent(as % of GDP) in Mauritania?
Provide a short and direct response. -9.03. In the year 2008, what is the difference between the Rent(as % of GDP) in Iraq and Rent(as % of GDP) in Mauritania?
Your answer should be very brief. 46.08. In the year 2009, what is the difference between the Rent(as % of GDP) of Bolivia and Rent(as % of GDP) of Guatemala?
Keep it short and to the point. 3.5. In the year 2009, what is the difference between the Rent(as % of GDP) of Bolivia and Rent(as % of GDP) of Iraq?
Provide a short and direct response. -36.76. In the year 2009, what is the difference between the Rent(as % of GDP) in Bolivia and Rent(as % of GDP) in Mauritania?
Ensure brevity in your answer.  -1.56. In the year 2009, what is the difference between the Rent(as % of GDP) of Guatemala and Rent(as % of GDP) of Iraq?
Your answer should be very brief. -40.25. In the year 2009, what is the difference between the Rent(as % of GDP) in Guatemala and Rent(as % of GDP) in Mauritania?
Your response must be concise. -5.05. In the year 2009, what is the difference between the Rent(as % of GDP) of Iraq and Rent(as % of GDP) of Mauritania?
Your response must be concise. 35.2. In the year 2010, what is the difference between the Rent(as % of GDP) of Bolivia and Rent(as % of GDP) of Guatemala?
Your answer should be very brief. 4.39. In the year 2010, what is the difference between the Rent(as % of GDP) of Bolivia and Rent(as % of GDP) of Iraq?
Provide a short and direct response. -38.09. In the year 2010, what is the difference between the Rent(as % of GDP) in Bolivia and Rent(as % of GDP) in Mauritania?
Ensure brevity in your answer.  0.45. In the year 2010, what is the difference between the Rent(as % of GDP) in Guatemala and Rent(as % of GDP) in Iraq?
Provide a succinct answer. -42.48. In the year 2010, what is the difference between the Rent(as % of GDP) in Guatemala and Rent(as % of GDP) in Mauritania?
Your answer should be very brief. -3.94. In the year 2010, what is the difference between the Rent(as % of GDP) in Iraq and Rent(as % of GDP) in Mauritania?
Give a very brief answer. 38.54. In the year 2011, what is the difference between the Rent(as % of GDP) in Bolivia and Rent(as % of GDP) in Guatemala?
Your answer should be very brief. 5.06. In the year 2011, what is the difference between the Rent(as % of GDP) of Bolivia and Rent(as % of GDP) of Iraq?
Provide a succinct answer. -42.46. In the year 2011, what is the difference between the Rent(as % of GDP) of Bolivia and Rent(as % of GDP) of Mauritania?
Your answer should be very brief. 0.88. In the year 2011, what is the difference between the Rent(as % of GDP) in Guatemala and Rent(as % of GDP) in Iraq?
Offer a terse response. -47.53. In the year 2011, what is the difference between the Rent(as % of GDP) of Guatemala and Rent(as % of GDP) of Mauritania?
Make the answer very short. -4.19. In the year 2011, what is the difference between the Rent(as % of GDP) in Iraq and Rent(as % of GDP) in Mauritania?
Your answer should be compact. 43.34. In the year 2012, what is the difference between the Rent(as % of GDP) of Bolivia and Rent(as % of GDP) of Guatemala?
Make the answer very short. 5.17. In the year 2012, what is the difference between the Rent(as % of GDP) in Bolivia and Rent(as % of GDP) in Iraq?
Offer a terse response. -39.34. In the year 2012, what is the difference between the Rent(as % of GDP) of Bolivia and Rent(as % of GDP) of Mauritania?
Make the answer very short. 1.47. In the year 2012, what is the difference between the Rent(as % of GDP) of Guatemala and Rent(as % of GDP) of Iraq?
Make the answer very short. -44.51. In the year 2012, what is the difference between the Rent(as % of GDP) in Iraq and Rent(as % of GDP) in Mauritania?
Make the answer very short. 40.81. In the year 2013, what is the difference between the Rent(as % of GDP) in Bolivia and Rent(as % of GDP) in Guatemala?
Your answer should be very brief. 4.29. In the year 2013, what is the difference between the Rent(as % of GDP) of Bolivia and Rent(as % of GDP) of Iraq?
Ensure brevity in your answer.  -38.07. In the year 2013, what is the difference between the Rent(as % of GDP) in Bolivia and Rent(as % of GDP) in Mauritania?
Your answer should be very brief. 0.7. In the year 2013, what is the difference between the Rent(as % of GDP) of Guatemala and Rent(as % of GDP) of Iraq?
Keep it short and to the point. -42.37. In the year 2013, what is the difference between the Rent(as % of GDP) in Guatemala and Rent(as % of GDP) in Mauritania?
Ensure brevity in your answer.  -3.59. In the year 2013, what is the difference between the Rent(as % of GDP) in Iraq and Rent(as % of GDP) in Mauritania?
Make the answer very short. 38.78. What is the ratio of the Rent(as % of GDP) of Bolivia in 2006 to that in 2007?
Your answer should be very brief. 1.03. What is the ratio of the Rent(as % of GDP) of Guatemala in 2006 to that in 2007?
Your response must be concise. 1.08. What is the ratio of the Rent(as % of GDP) of Iraq in 2006 to that in 2007?
Give a very brief answer. 1.19. What is the ratio of the Rent(as % of GDP) in Mauritania in 2006 to that in 2007?
Your response must be concise. 2.05. What is the ratio of the Rent(as % of GDP) of Guatemala in 2006 to that in 2008?
Offer a very short reply. 0.98. What is the ratio of the Rent(as % of GDP) in Iraq in 2006 to that in 2008?
Your answer should be very brief. 1.15. What is the ratio of the Rent(as % of GDP) in Mauritania in 2006 to that in 2008?
Give a very brief answer. 2.08. What is the ratio of the Rent(as % of GDP) of Bolivia in 2006 to that in 2009?
Offer a terse response. 2.1. What is the ratio of the Rent(as % of GDP) in Guatemala in 2006 to that in 2009?
Ensure brevity in your answer.  1.72. What is the ratio of the Rent(as % of GDP) in Iraq in 2006 to that in 2009?
Make the answer very short. 1.59. What is the ratio of the Rent(as % of GDP) in Mauritania in 2006 to that in 2009?
Give a very brief answer. 3.72. What is the ratio of the Rent(as % of GDP) in Bolivia in 2006 to that in 2010?
Your response must be concise. 1.72. What is the ratio of the Rent(as % of GDP) of Guatemala in 2006 to that in 2010?
Your response must be concise. 1.61. What is the ratio of the Rent(as % of GDP) of Iraq in 2006 to that in 2010?
Ensure brevity in your answer.  1.5. What is the ratio of the Rent(as % of GDP) of Mauritania in 2006 to that in 2010?
Keep it short and to the point. 4.58. What is the ratio of the Rent(as % of GDP) of Bolivia in 2006 to that in 2011?
Provide a succinct answer. 1.5. What is the ratio of the Rent(as % of GDP) of Guatemala in 2006 to that in 2011?
Keep it short and to the point. 1.51. What is the ratio of the Rent(as % of GDP) in Iraq in 2006 to that in 2011?
Provide a succinct answer. 1.35. What is the ratio of the Rent(as % of GDP) of Mauritania in 2006 to that in 2011?
Offer a very short reply. 4.31. What is the ratio of the Rent(as % of GDP) of Bolivia in 2006 to that in 2012?
Offer a terse response. 1.49. What is the ratio of the Rent(as % of GDP) in Guatemala in 2006 to that in 2012?
Provide a succinct answer. 1.68. What is the ratio of the Rent(as % of GDP) in Iraq in 2006 to that in 2012?
Your answer should be very brief. 1.44. What is the ratio of the Rent(as % of GDP) of Mauritania in 2006 to that in 2012?
Offer a very short reply. 4.86. What is the ratio of the Rent(as % of GDP) of Bolivia in 2006 to that in 2013?
Keep it short and to the point. 1.8. What is the ratio of the Rent(as % of GDP) in Guatemala in 2006 to that in 2013?
Make the answer very short. 2.09. What is the ratio of the Rent(as % of GDP) in Iraq in 2006 to that in 2013?
Offer a very short reply. 1.51. What is the ratio of the Rent(as % of GDP) in Mauritania in 2006 to that in 2013?
Your answer should be very brief. 5.14. What is the ratio of the Rent(as % of GDP) in Bolivia in 2007 to that in 2008?
Make the answer very short. 0.97. What is the ratio of the Rent(as % of GDP) in Guatemala in 2007 to that in 2008?
Give a very brief answer. 0.9. What is the ratio of the Rent(as % of GDP) of Iraq in 2007 to that in 2008?
Your response must be concise. 0.97. What is the ratio of the Rent(as % of GDP) in Mauritania in 2007 to that in 2008?
Ensure brevity in your answer.  1.02. What is the ratio of the Rent(as % of GDP) in Bolivia in 2007 to that in 2009?
Make the answer very short. 2.04. What is the ratio of the Rent(as % of GDP) of Guatemala in 2007 to that in 2009?
Provide a short and direct response. 1.59. What is the ratio of the Rent(as % of GDP) in Iraq in 2007 to that in 2009?
Your answer should be compact. 1.34. What is the ratio of the Rent(as % of GDP) of Mauritania in 2007 to that in 2009?
Your answer should be very brief. 1.82. What is the ratio of the Rent(as % of GDP) in Bolivia in 2007 to that in 2010?
Your answer should be compact. 1.66. What is the ratio of the Rent(as % of GDP) in Guatemala in 2007 to that in 2010?
Make the answer very short. 1.48. What is the ratio of the Rent(as % of GDP) in Iraq in 2007 to that in 2010?
Offer a very short reply. 1.27. What is the ratio of the Rent(as % of GDP) in Mauritania in 2007 to that in 2010?
Make the answer very short. 2.24. What is the ratio of the Rent(as % of GDP) of Bolivia in 2007 to that in 2011?
Your response must be concise. 1.46. What is the ratio of the Rent(as % of GDP) of Guatemala in 2007 to that in 2011?
Offer a terse response. 1.39. What is the ratio of the Rent(as % of GDP) in Iraq in 2007 to that in 2011?
Provide a short and direct response. 1.13. What is the ratio of the Rent(as % of GDP) of Mauritania in 2007 to that in 2011?
Your response must be concise. 2.1. What is the ratio of the Rent(as % of GDP) of Bolivia in 2007 to that in 2012?
Your answer should be compact. 1.45. What is the ratio of the Rent(as % of GDP) of Guatemala in 2007 to that in 2012?
Your answer should be very brief. 1.56. What is the ratio of the Rent(as % of GDP) of Iraq in 2007 to that in 2012?
Give a very brief answer. 1.21. What is the ratio of the Rent(as % of GDP) in Mauritania in 2007 to that in 2012?
Keep it short and to the point. 2.38. What is the ratio of the Rent(as % of GDP) in Bolivia in 2007 to that in 2013?
Offer a very short reply. 1.75. What is the ratio of the Rent(as % of GDP) of Guatemala in 2007 to that in 2013?
Give a very brief answer. 1.93. What is the ratio of the Rent(as % of GDP) in Iraq in 2007 to that in 2013?
Give a very brief answer. 1.27. What is the ratio of the Rent(as % of GDP) in Mauritania in 2007 to that in 2013?
Your response must be concise. 2.51. What is the ratio of the Rent(as % of GDP) in Bolivia in 2008 to that in 2009?
Keep it short and to the point. 2.11. What is the ratio of the Rent(as % of GDP) of Guatemala in 2008 to that in 2009?
Keep it short and to the point. 1.76. What is the ratio of the Rent(as % of GDP) of Iraq in 2008 to that in 2009?
Provide a short and direct response. 1.38. What is the ratio of the Rent(as % of GDP) of Mauritania in 2008 to that in 2009?
Give a very brief answer. 1.78. What is the ratio of the Rent(as % of GDP) of Bolivia in 2008 to that in 2010?
Your answer should be compact. 1.72. What is the ratio of the Rent(as % of GDP) in Guatemala in 2008 to that in 2010?
Make the answer very short. 1.65. What is the ratio of the Rent(as % of GDP) of Iraq in 2008 to that in 2010?
Keep it short and to the point. 1.3. What is the ratio of the Rent(as % of GDP) of Mauritania in 2008 to that in 2010?
Ensure brevity in your answer.  2.2. What is the ratio of the Rent(as % of GDP) of Bolivia in 2008 to that in 2011?
Provide a short and direct response. 1.5. What is the ratio of the Rent(as % of GDP) of Guatemala in 2008 to that in 2011?
Your answer should be compact. 1.55. What is the ratio of the Rent(as % of GDP) of Iraq in 2008 to that in 2011?
Ensure brevity in your answer.  1.17. What is the ratio of the Rent(as % of GDP) in Mauritania in 2008 to that in 2011?
Give a very brief answer. 2.07. What is the ratio of the Rent(as % of GDP) of Bolivia in 2008 to that in 2012?
Ensure brevity in your answer.  1.5. What is the ratio of the Rent(as % of GDP) in Guatemala in 2008 to that in 2012?
Your answer should be compact. 1.73. What is the ratio of the Rent(as % of GDP) in Iraq in 2008 to that in 2012?
Your response must be concise. 1.25. What is the ratio of the Rent(as % of GDP) of Mauritania in 2008 to that in 2012?
Offer a very short reply. 2.33. What is the ratio of the Rent(as % of GDP) of Bolivia in 2008 to that in 2013?
Your answer should be compact. 1.81. What is the ratio of the Rent(as % of GDP) in Guatemala in 2008 to that in 2013?
Provide a short and direct response. 2.14. What is the ratio of the Rent(as % of GDP) of Iraq in 2008 to that in 2013?
Offer a terse response. 1.31. What is the ratio of the Rent(as % of GDP) in Mauritania in 2008 to that in 2013?
Keep it short and to the point. 2.47. What is the ratio of the Rent(as % of GDP) in Bolivia in 2009 to that in 2010?
Provide a short and direct response. 0.82. What is the ratio of the Rent(as % of GDP) in Guatemala in 2009 to that in 2010?
Keep it short and to the point. 0.94. What is the ratio of the Rent(as % of GDP) of Iraq in 2009 to that in 2010?
Offer a very short reply. 0.95. What is the ratio of the Rent(as % of GDP) in Mauritania in 2009 to that in 2010?
Make the answer very short. 1.23. What is the ratio of the Rent(as % of GDP) in Bolivia in 2009 to that in 2011?
Provide a succinct answer. 0.71. What is the ratio of the Rent(as % of GDP) in Guatemala in 2009 to that in 2011?
Give a very brief answer. 0.88. What is the ratio of the Rent(as % of GDP) of Iraq in 2009 to that in 2011?
Make the answer very short. 0.85. What is the ratio of the Rent(as % of GDP) of Mauritania in 2009 to that in 2011?
Keep it short and to the point. 1.16. What is the ratio of the Rent(as % of GDP) in Bolivia in 2009 to that in 2012?
Offer a terse response. 0.71. What is the ratio of the Rent(as % of GDP) of Guatemala in 2009 to that in 2012?
Give a very brief answer. 0.98. What is the ratio of the Rent(as % of GDP) in Iraq in 2009 to that in 2012?
Offer a terse response. 0.91. What is the ratio of the Rent(as % of GDP) of Mauritania in 2009 to that in 2012?
Ensure brevity in your answer.  1.31. What is the ratio of the Rent(as % of GDP) in Bolivia in 2009 to that in 2013?
Provide a succinct answer. 0.86. What is the ratio of the Rent(as % of GDP) of Guatemala in 2009 to that in 2013?
Offer a very short reply. 1.22. What is the ratio of the Rent(as % of GDP) of Iraq in 2009 to that in 2013?
Your answer should be very brief. 0.95. What is the ratio of the Rent(as % of GDP) of Mauritania in 2009 to that in 2013?
Ensure brevity in your answer.  1.38. What is the ratio of the Rent(as % of GDP) in Bolivia in 2010 to that in 2011?
Your answer should be very brief. 0.88. What is the ratio of the Rent(as % of GDP) of Guatemala in 2010 to that in 2011?
Ensure brevity in your answer.  0.94. What is the ratio of the Rent(as % of GDP) of Iraq in 2010 to that in 2011?
Your answer should be very brief. 0.89. What is the ratio of the Rent(as % of GDP) of Mauritania in 2010 to that in 2011?
Give a very brief answer. 0.94. What is the ratio of the Rent(as % of GDP) in Bolivia in 2010 to that in 2012?
Offer a terse response. 0.87. What is the ratio of the Rent(as % of GDP) of Guatemala in 2010 to that in 2012?
Your answer should be very brief. 1.05. What is the ratio of the Rent(as % of GDP) of Iraq in 2010 to that in 2012?
Offer a very short reply. 0.96. What is the ratio of the Rent(as % of GDP) in Mauritania in 2010 to that in 2012?
Make the answer very short. 1.06. What is the ratio of the Rent(as % of GDP) of Bolivia in 2010 to that in 2013?
Make the answer very short. 1.05. What is the ratio of the Rent(as % of GDP) in Guatemala in 2010 to that in 2013?
Offer a terse response. 1.3. What is the ratio of the Rent(as % of GDP) of Mauritania in 2010 to that in 2013?
Your response must be concise. 1.12. What is the ratio of the Rent(as % of GDP) in Guatemala in 2011 to that in 2012?
Your answer should be compact. 1.12. What is the ratio of the Rent(as % of GDP) of Iraq in 2011 to that in 2012?
Provide a short and direct response. 1.07. What is the ratio of the Rent(as % of GDP) in Mauritania in 2011 to that in 2012?
Provide a short and direct response. 1.13. What is the ratio of the Rent(as % of GDP) in Bolivia in 2011 to that in 2013?
Ensure brevity in your answer.  1.2. What is the ratio of the Rent(as % of GDP) of Guatemala in 2011 to that in 2013?
Keep it short and to the point. 1.39. What is the ratio of the Rent(as % of GDP) in Iraq in 2011 to that in 2013?
Offer a very short reply. 1.12. What is the ratio of the Rent(as % of GDP) in Mauritania in 2011 to that in 2013?
Ensure brevity in your answer.  1.19. What is the ratio of the Rent(as % of GDP) of Bolivia in 2012 to that in 2013?
Your response must be concise. 1.21. What is the ratio of the Rent(as % of GDP) of Guatemala in 2012 to that in 2013?
Keep it short and to the point. 1.24. What is the ratio of the Rent(as % of GDP) in Iraq in 2012 to that in 2013?
Ensure brevity in your answer.  1.05. What is the ratio of the Rent(as % of GDP) in Mauritania in 2012 to that in 2013?
Provide a succinct answer. 1.06. What is the difference between the highest and the second highest Rent(as % of GDP) of Bolivia?
Your answer should be very brief. 0.01. What is the difference between the highest and the second highest Rent(as % of GDP) in Guatemala?
Ensure brevity in your answer.  0.03. What is the difference between the highest and the second highest Rent(as % of GDP) in Iraq?
Offer a terse response. 8.68. What is the difference between the highest and the second highest Rent(as % of GDP) in Mauritania?
Give a very brief answer. 10.8. What is the difference between the highest and the lowest Rent(as % of GDP) of Bolivia?
Keep it short and to the point. 4.57. What is the difference between the highest and the lowest Rent(as % of GDP) in Guatemala?
Your answer should be very brief. 0.59. What is the difference between the highest and the lowest Rent(as % of GDP) of Iraq?
Your answer should be compact. 24.02. What is the difference between the highest and the lowest Rent(as % of GDP) in Mauritania?
Offer a very short reply. 17.01. 